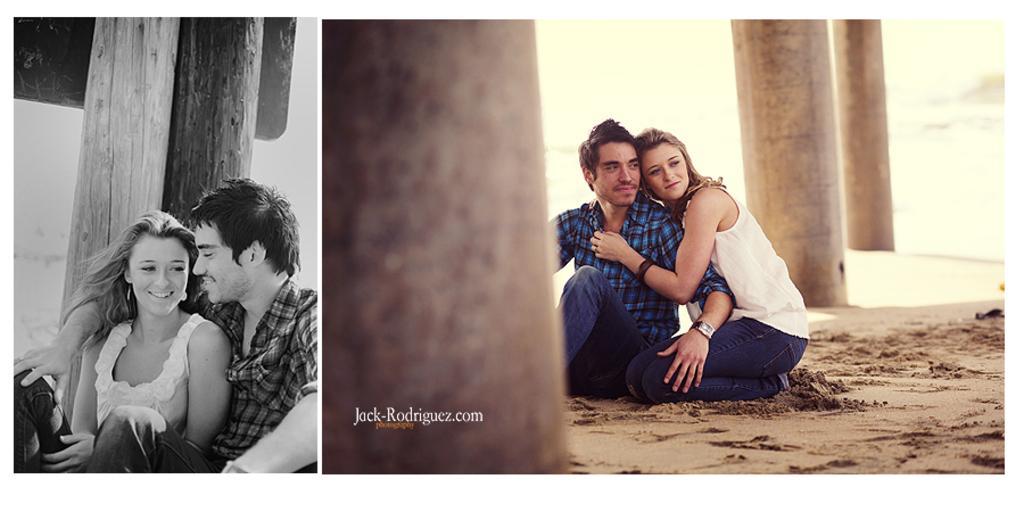Describe this image in one or two sentences. This is a collage picture. Here we can see a man and a woman. And there are pillars. 